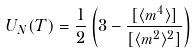Convert formula to latex. <formula><loc_0><loc_0><loc_500><loc_500>U _ { N } ( T ) = \frac { 1 } { 2 } \left ( 3 - \frac { [ \langle m ^ { 4 } \rangle ] } { [ \langle m ^ { 2 } \rangle ^ { 2 } ] } \right )</formula> 